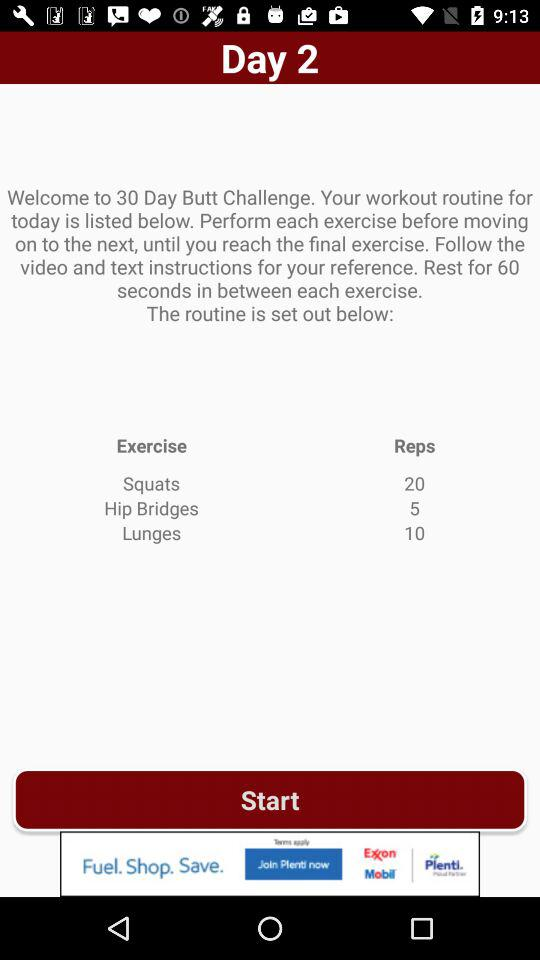What is the number of reps in squats? The number of reps is 20. 